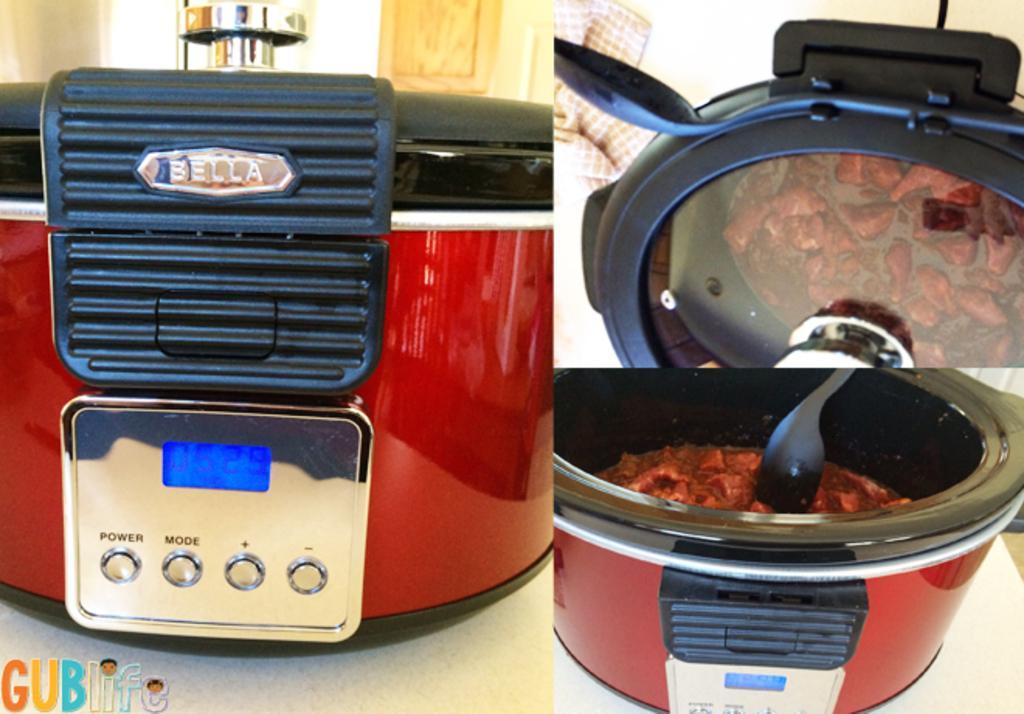Could you give a brief overview of what you see in this image? This is an edited image with the collage of images. On the left we can see a cooking utensil and we can see the buttons and the text and the numbers on the utensil. On the right we can see a spoon and some food items in the utensil and we can see some other objects. In the bottom left corner we can see the watermark on the image. 